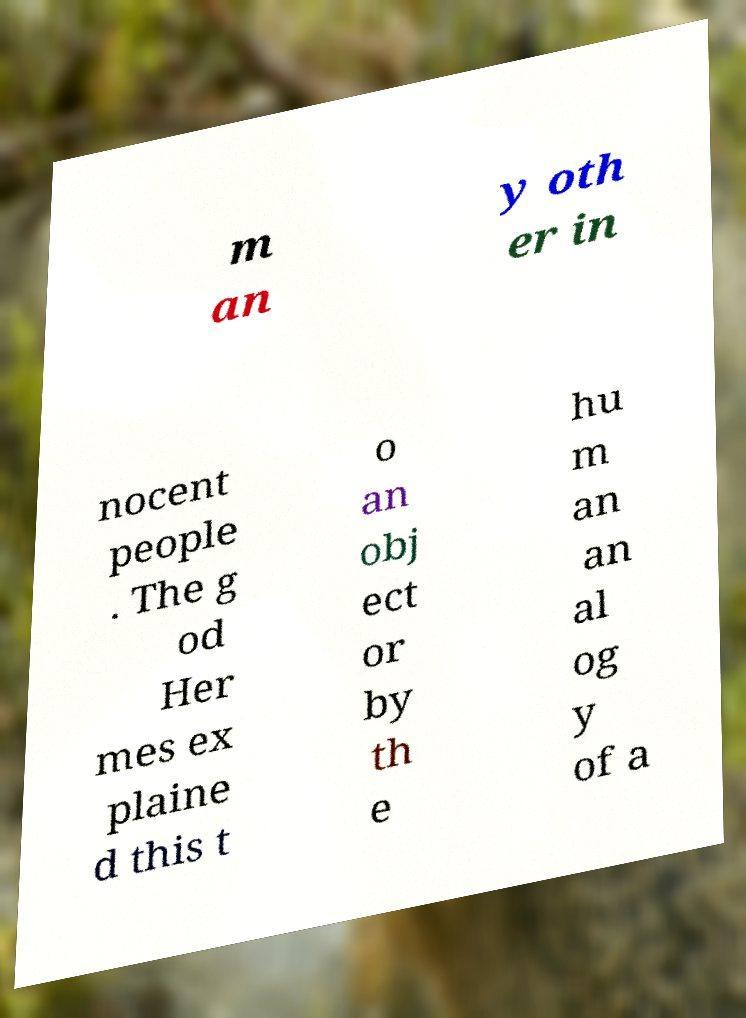Please identify and transcribe the text found in this image. m an y oth er in nocent people . The g od Her mes ex plaine d this t o an obj ect or by th e hu m an an al og y of a 